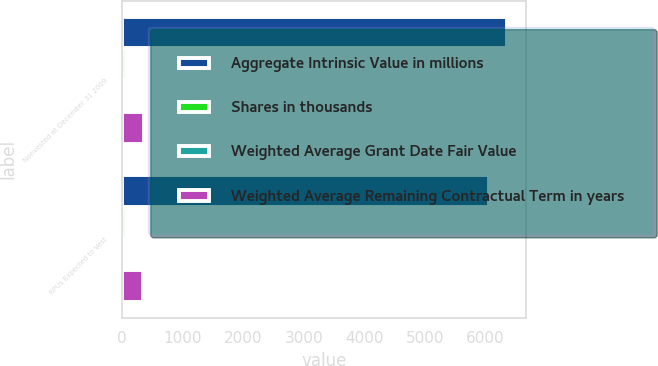<chart> <loc_0><loc_0><loc_500><loc_500><stacked_bar_chart><ecel><fcel>Nonvested at December 31 2009<fcel>RPUs Expected to Vest<nl><fcel>Aggregate Intrinsic Value in millions<fcel>6361<fcel>6056<nl><fcel>Shares in thousands<fcel>67.25<fcel>67.28<nl><fcel>Weighted Average Grant Date Fair Value<fcel>1.84<fcel>1.81<nl><fcel>Weighted Average Remaining Contractual Term in years<fcel>365<fcel>347<nl></chart> 